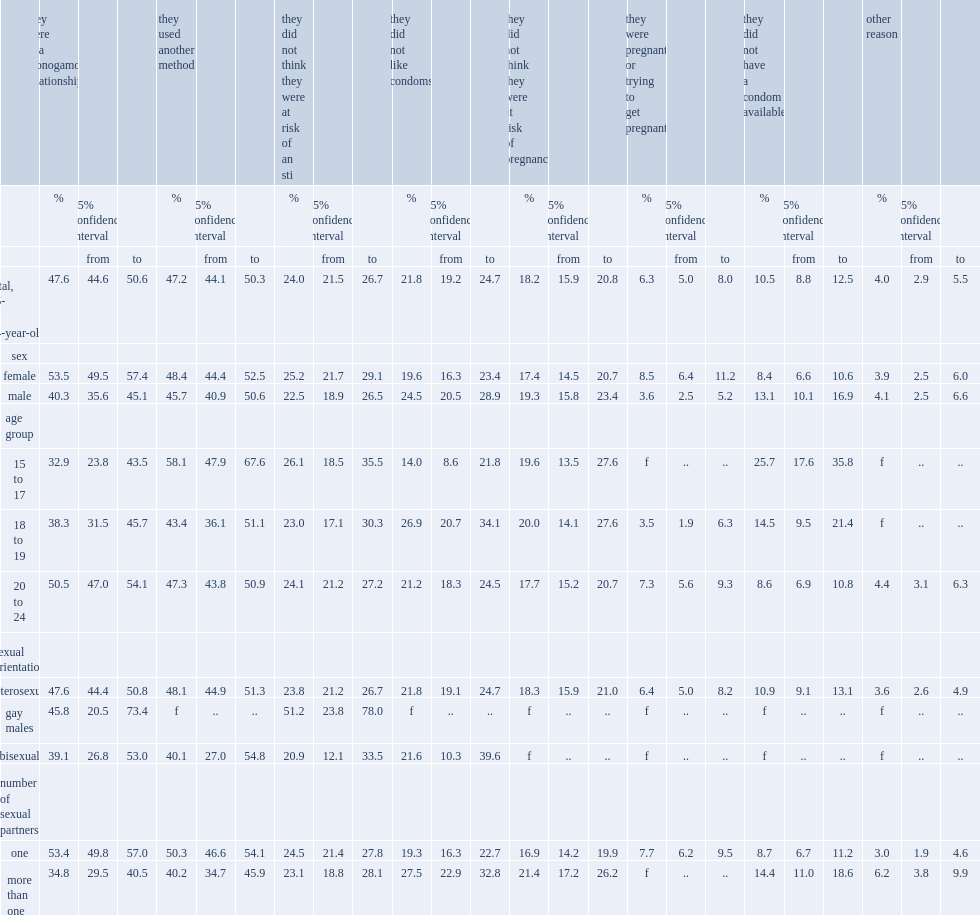What was the percentage of individuals who reported not using a condom the last time they had sex who had the reason that they were in a monogamous relationship? 47.6. What was the percentage of individuals who reported not using a condom the last time they had sex thought they were not at risk of an sti? 24.0. What was the percentage of individuals who reported not using a condom the last time they had sex did not like condoms? 21.8. What was the percentage of individuals who reported not using a condom the last time they had sex thought they were not at risk of pregnancy? 18.2. Which age group of people were more likely to cite being in a monogamous relationship as a reason for not using a condom? 20 to 24. By number of sexual partners,which kind of people were more likely to select not liking condoms as a reason for not using a condom?people with one partner or with more than one partners? More than one. What was the times the rates of not using a condom because one was unavailable higher among 15- to 17-year-olds than among youth aged 20 to 24? 2.988372. By number of sexual partners,which kind of people were more likely to select condoms were unavailable as a reason for not using a condom?people with one partner or with more than one partners? More than one. 